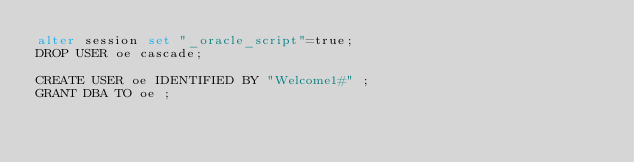<code> <loc_0><loc_0><loc_500><loc_500><_SQL_>alter session set "_oracle_script"=true;
DROP USER oe cascade;

CREATE USER oe IDENTIFIED BY "Welcome1#" ;
GRANT DBA TO oe ;
</code> 